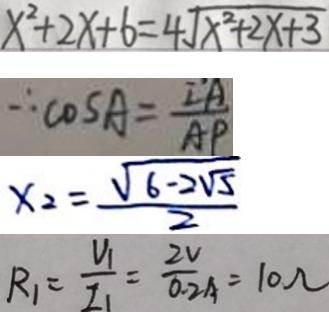Convert formula to latex. <formula><loc_0><loc_0><loc_500><loc_500>x ^ { 2 } + 2 x + 6 = 4 \sqrt { x ^ { 2 } + 2 x + 3 } 
 \therefore \cos A = \frac { I A } { A P } 
 x _ { 2 } = \frac { \sqrt { 6 - 2 \sqrt { 5 } } } { 2 } 
 R _ { 1 } = \frac { U _ { 1 } } { I _ { 1 } } = \frac { 2 V } { 0 . 2 A } = 1 0 \Omega</formula> 